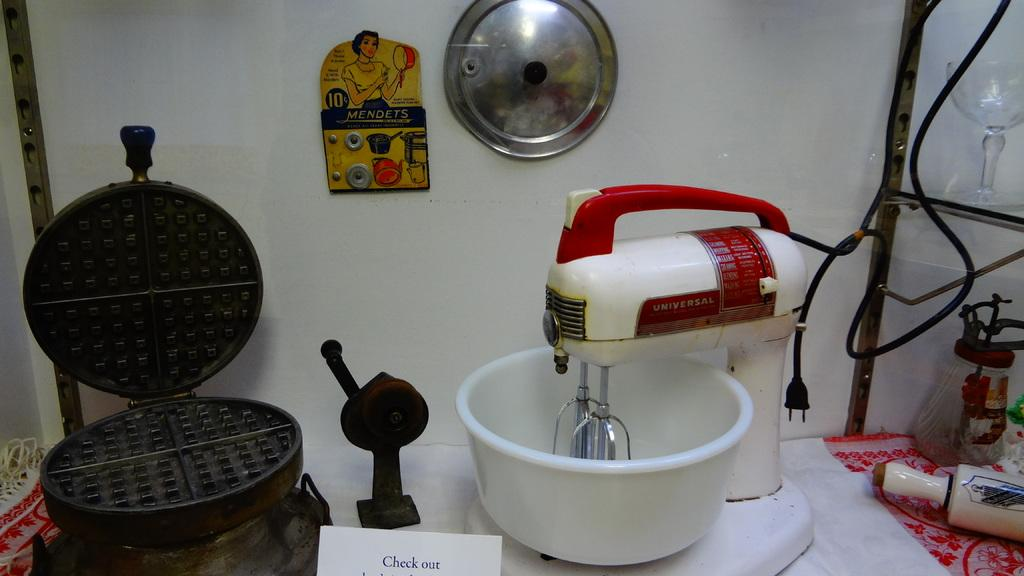Provide a one-sentence caption for the provided image. a waffle iron and mixer with a sign reading Check Out. 